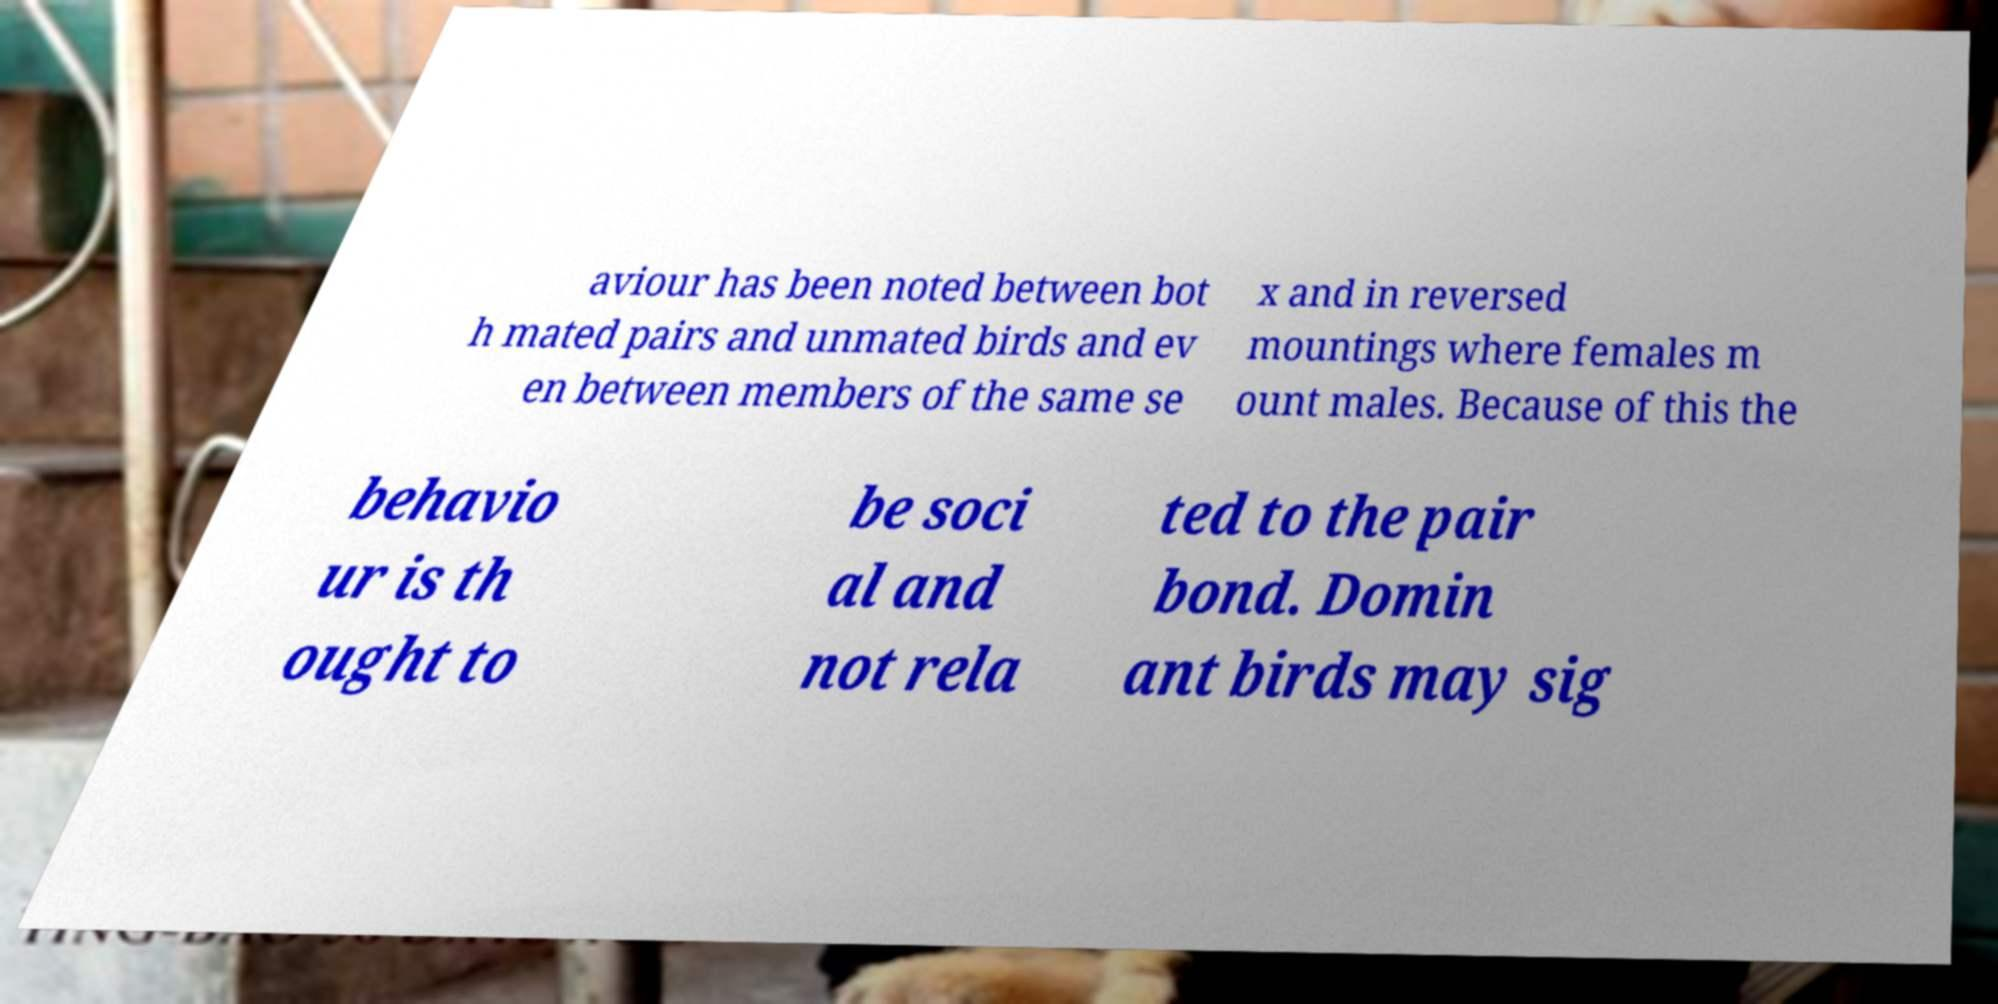What might 'Dominant birds may sig' imply about their behavior? The phrase 'Dominant birds may sig' seems to be cut off, but it likely refers to dominant birds signaling or exhibiting certain behaviors that assert their status within the flock. This can involve displays of power, territorial calls, or other actions that reinforce their position in the social hierarchy. 